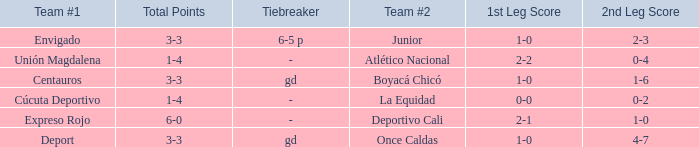What is the team #2 with Deport as team #1? Once Caldas. 